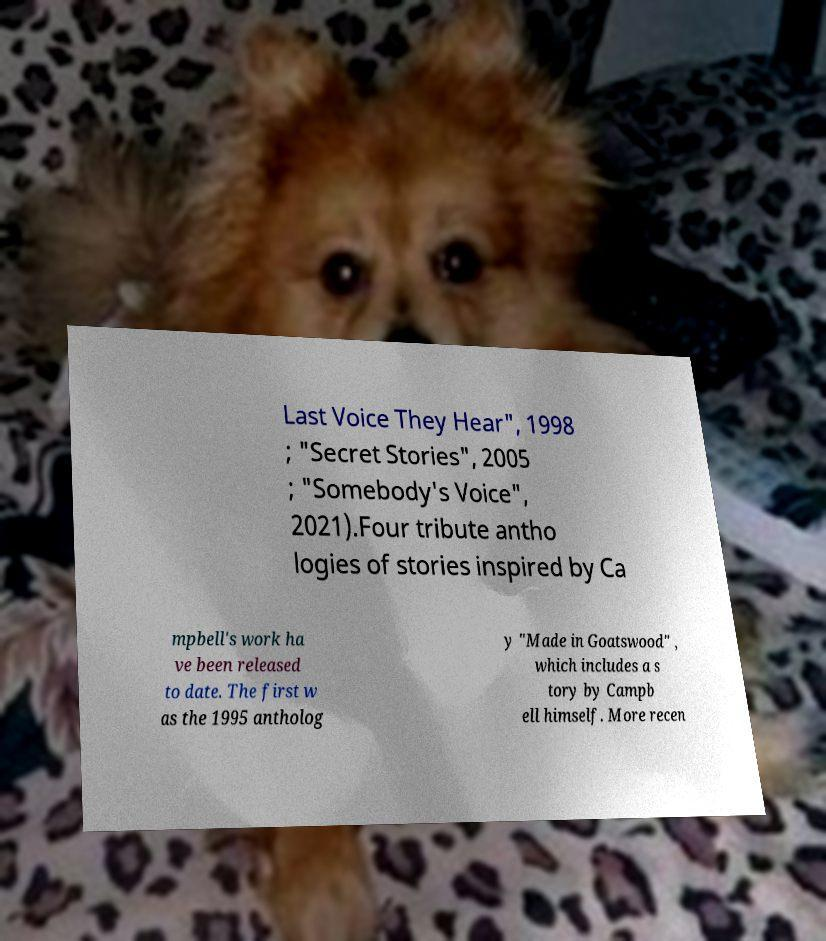For documentation purposes, I need the text within this image transcribed. Could you provide that? Last Voice They Hear", 1998 ; "Secret Stories", 2005 ; "Somebody's Voice", 2021).Four tribute antho logies of stories inspired by Ca mpbell's work ha ve been released to date. The first w as the 1995 antholog y "Made in Goatswood" , which includes a s tory by Campb ell himself. More recen 